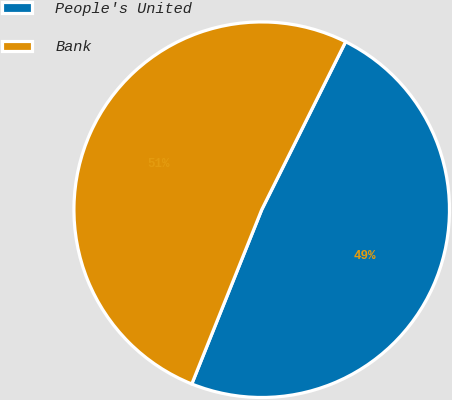Convert chart to OTSL. <chart><loc_0><loc_0><loc_500><loc_500><pie_chart><fcel>People's United<fcel>Bank<nl><fcel>48.7%<fcel>51.3%<nl></chart> 